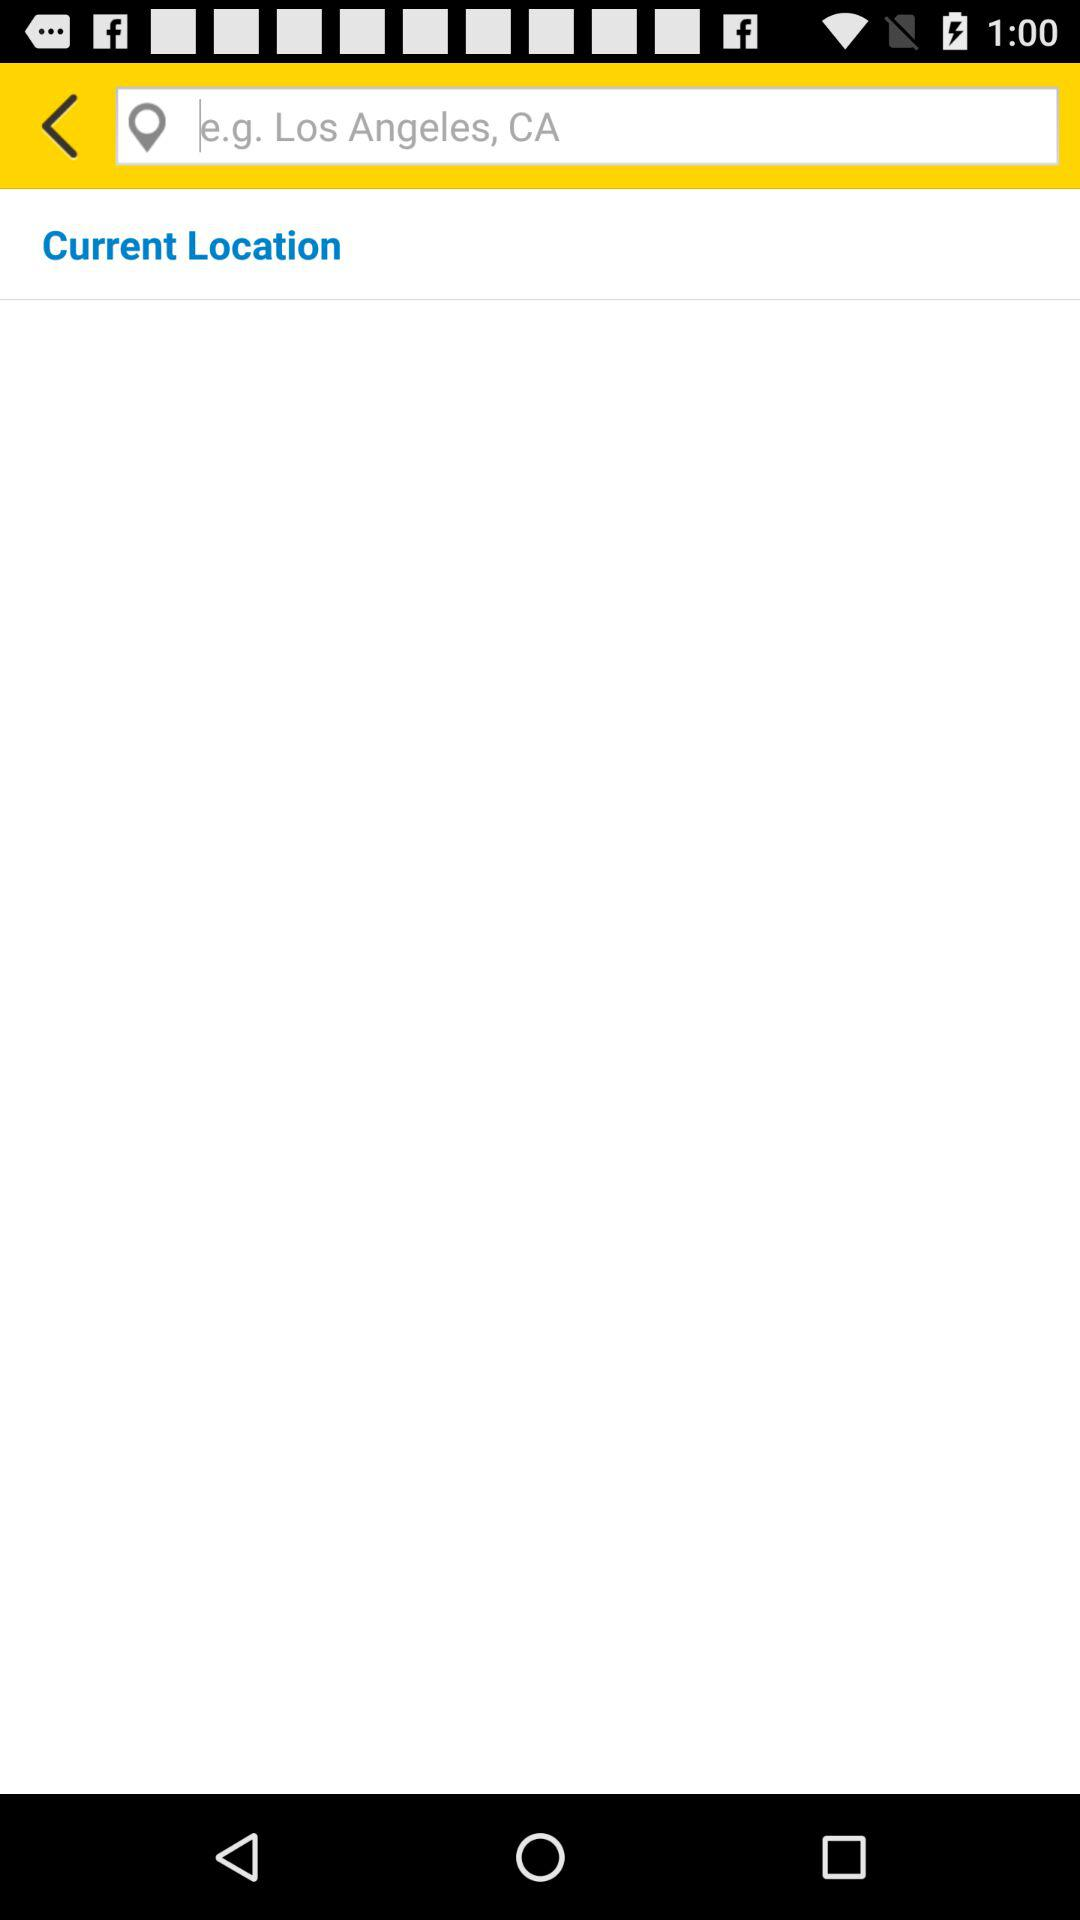What is the shown location in the input field? The shown location in the input field is Los Angeles, CA. 